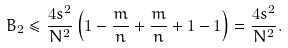<formula> <loc_0><loc_0><loc_500><loc_500>B _ { 2 } \leq \frac { 4 s ^ { 2 } } { N ^ { 2 } } \left ( 1 - \frac { m } { n } + \frac { m } { n } + 1 - 1 \right ) = \frac { 4 s ^ { 2 } } { N ^ { 2 } } .</formula> 